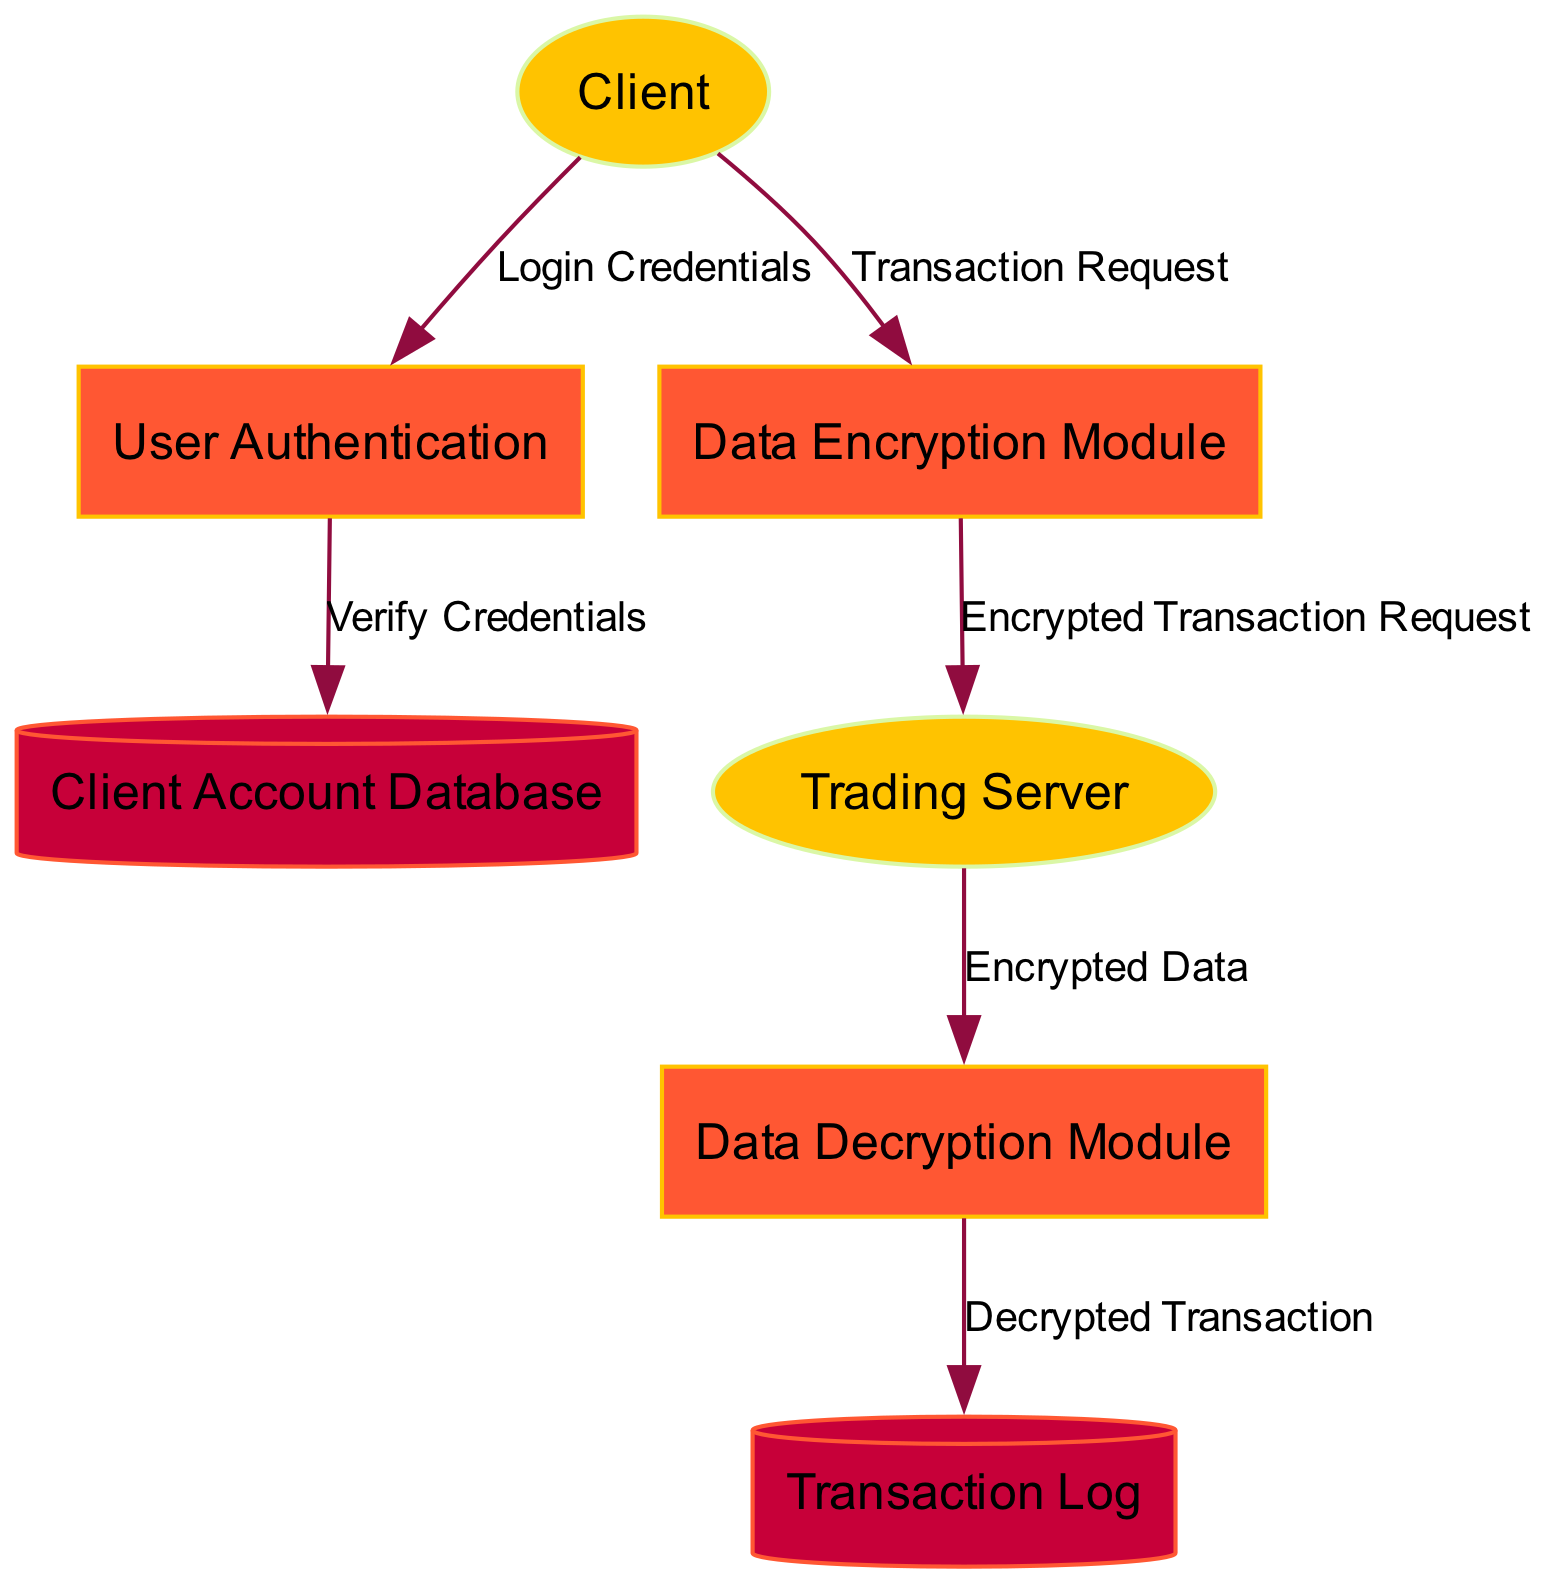What is the first step in the diagram? The first step involves the client initiating the transaction through the "User Authentication" process, which is depicted as the initial interaction originating from the "Client" external entity.
Answer: User Authentication How many external entities are present in the diagram? The diagram includes two external entities: the "Client" and the "Trading Server." They are represented with elliptical shapes, while the remaining elements in the diagram have different representations.
Answer: 2 What data flows from the "Data Encryption Module" to the "Trading Server"? The data that flows from the "Data Encryption Module" to the "Trading Server" is labeled as "Encrypted Transaction Request," illustrating the secure transmission of encrypted transaction data.
Answer: Encrypted Transaction Request What is stored in the "Transaction Log"? The "Transaction Log" is designated to securely store all transaction records for auditing purposes, ensuring a comprehensive tracking of all completed transactions.
Answer: Transaction records How do we verify the client's credentials? The client's credentials are verified by passing the "Login Credentials" from the "User Authentication" process to the "Client Account Database" process for validation.
Answer: Verify Credentials What process is responsible for decrypting data? The process responsible for decrypting data received by the trading server is termed the "Data Decryption Module," which handles the decryption of the encrypted transaction data.
Answer: Data Decryption Module What type of data flow occurs between the "Trading Server" and the "Data Decryption Module"? The type of data flow that occurs is labeled "Encrypted Data," indicating the secure transfer of encrypted data from the trading server to the decryption module for processing.
Answer: Encrypted Data What data is transmitted using secure protocols like TLS? The transmitted data using secure protocols, including TLS, is "Secure Data Transmission," which encompasses all encrypted data sent between the client and trading server.
Answer: Secure Data Transmission What do we receive after decrypting the transaction data? After decrypting the transaction data, the output is a "Decrypted Transaction," which is stored in the "Transaction Log" for future reference and auditing purposes.
Answer: Decrypted Transaction 